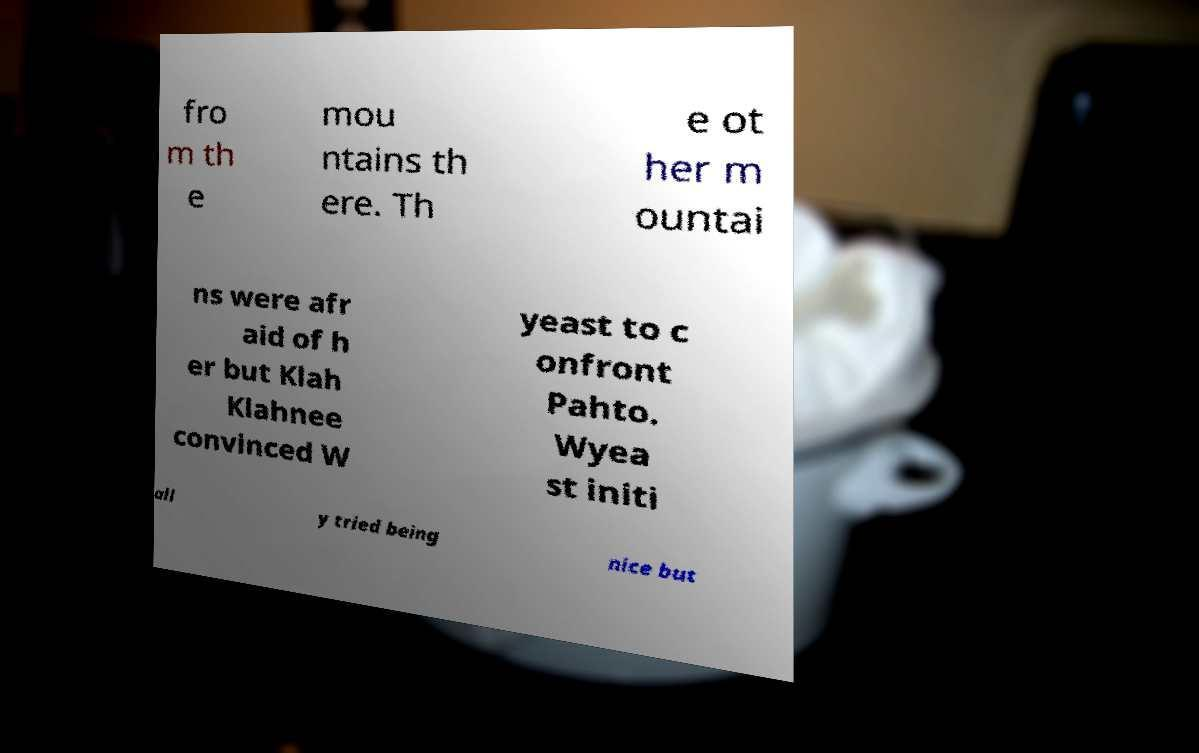I need the written content from this picture converted into text. Can you do that? fro m th e mou ntains th ere. Th e ot her m ountai ns were afr aid of h er but Klah Klahnee convinced W yeast to c onfront Pahto. Wyea st initi all y tried being nice but 